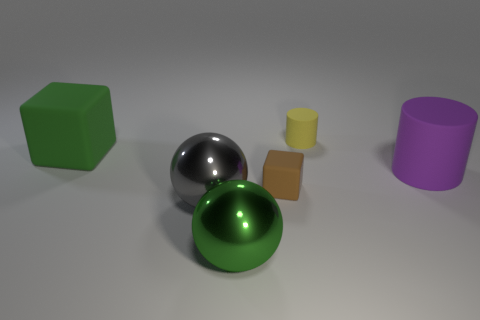Add 3 big brown rubber objects. How many objects exist? 9 Subtract all cylinders. How many objects are left? 4 Subtract 0 cyan blocks. How many objects are left? 6 Subtract all tiny rubber things. Subtract all green blocks. How many objects are left? 3 Add 3 gray things. How many gray things are left? 4 Add 1 green metal things. How many green metal things exist? 2 